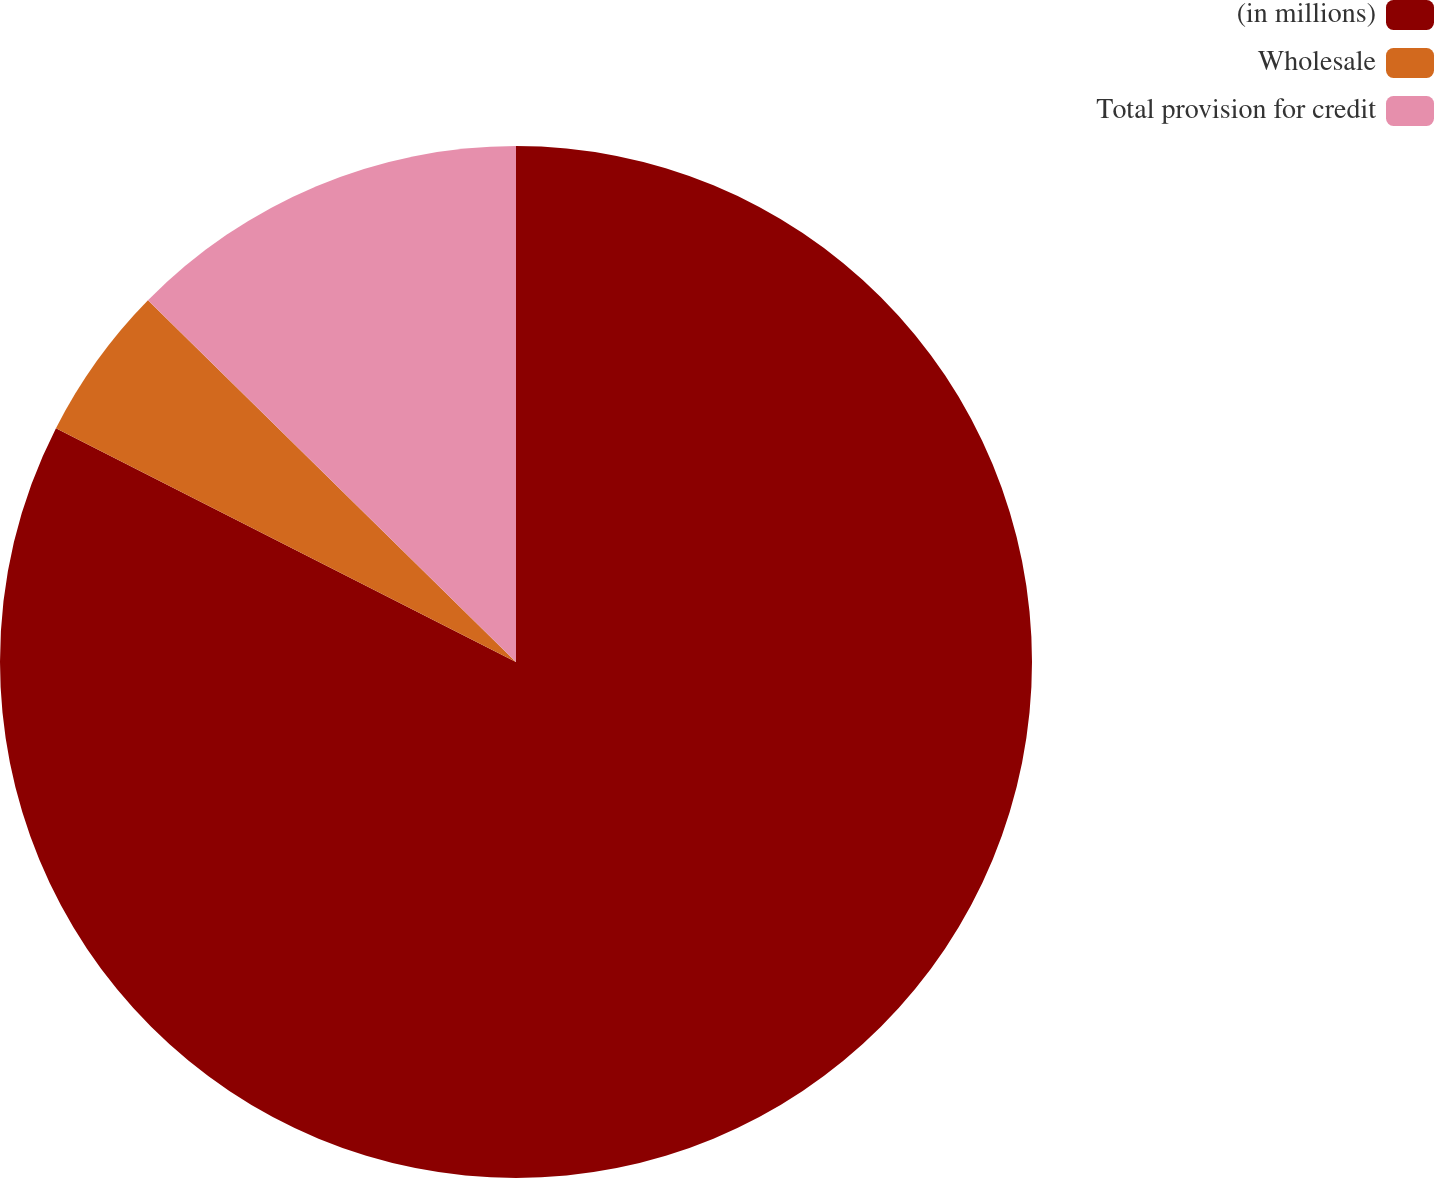Convert chart to OTSL. <chart><loc_0><loc_0><loc_500><loc_500><pie_chart><fcel>(in millions)<fcel>Wholesale<fcel>Total provision for credit<nl><fcel>82.49%<fcel>4.88%<fcel>12.64%<nl></chart> 